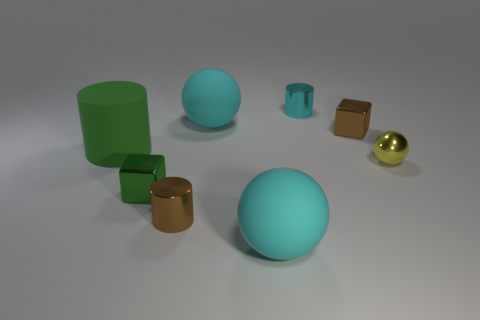What can you infer about the setting where these objects are placed? The objects are placed in a neutral environment with a soft shadow effect, suggesting indoor lighting, possibly indicating a controlled setting like a studio or a computer-generated scene. 